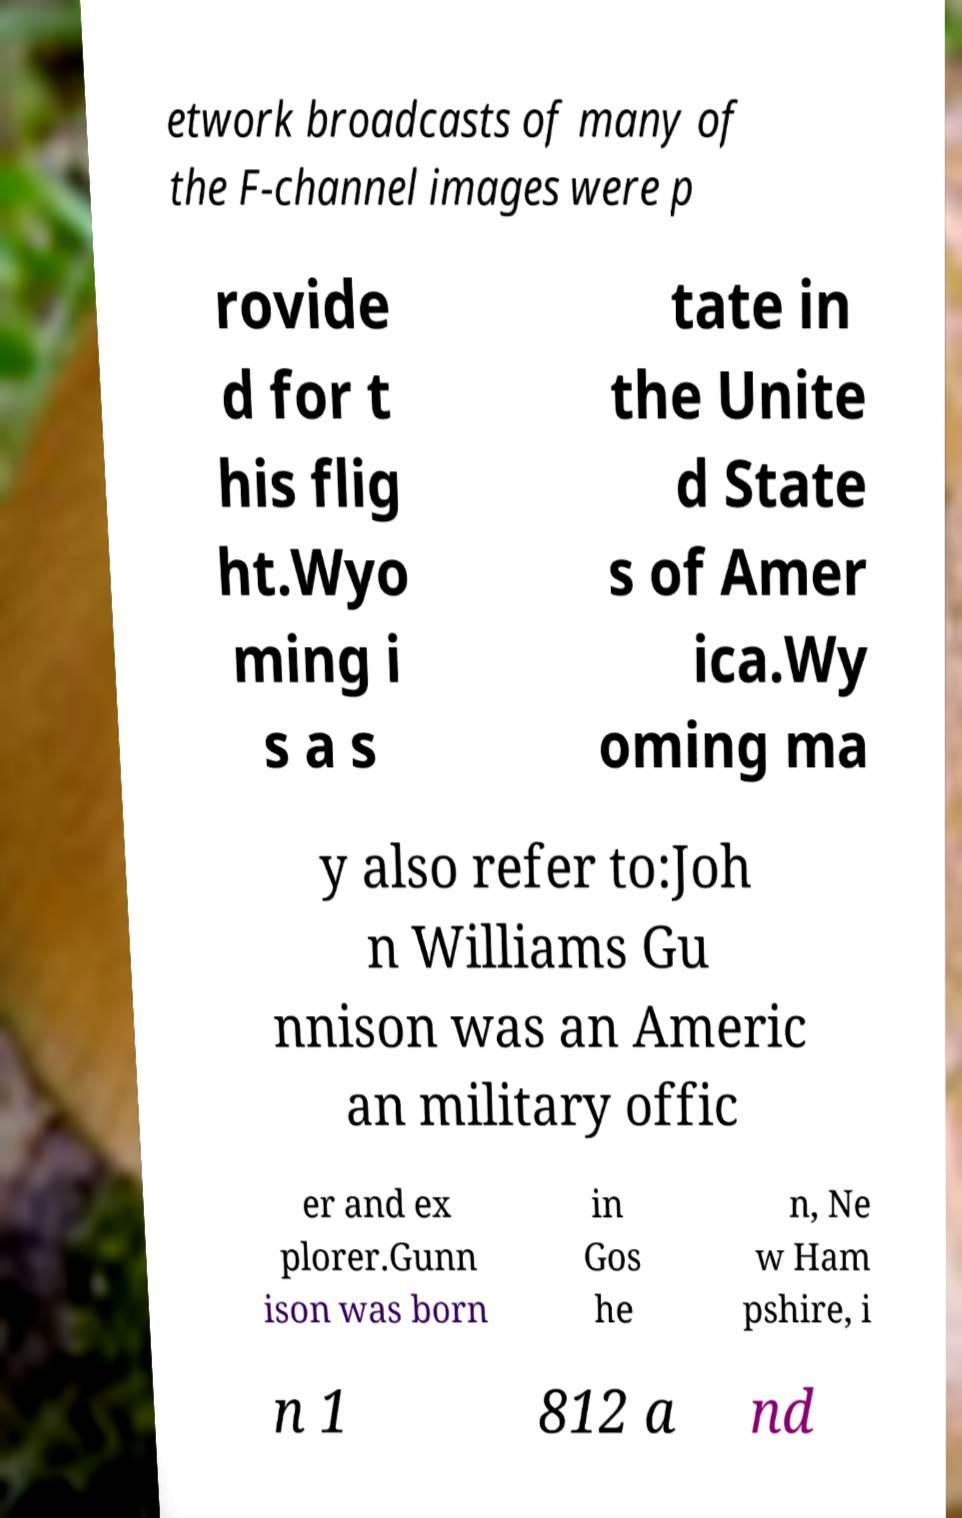Can you accurately transcribe the text from the provided image for me? etwork broadcasts of many of the F-channel images were p rovide d for t his flig ht.Wyo ming i s a s tate in the Unite d State s of Amer ica.Wy oming ma y also refer to:Joh n Williams Gu nnison was an Americ an military offic er and ex plorer.Gunn ison was born in Gos he n, Ne w Ham pshire, i n 1 812 a nd 